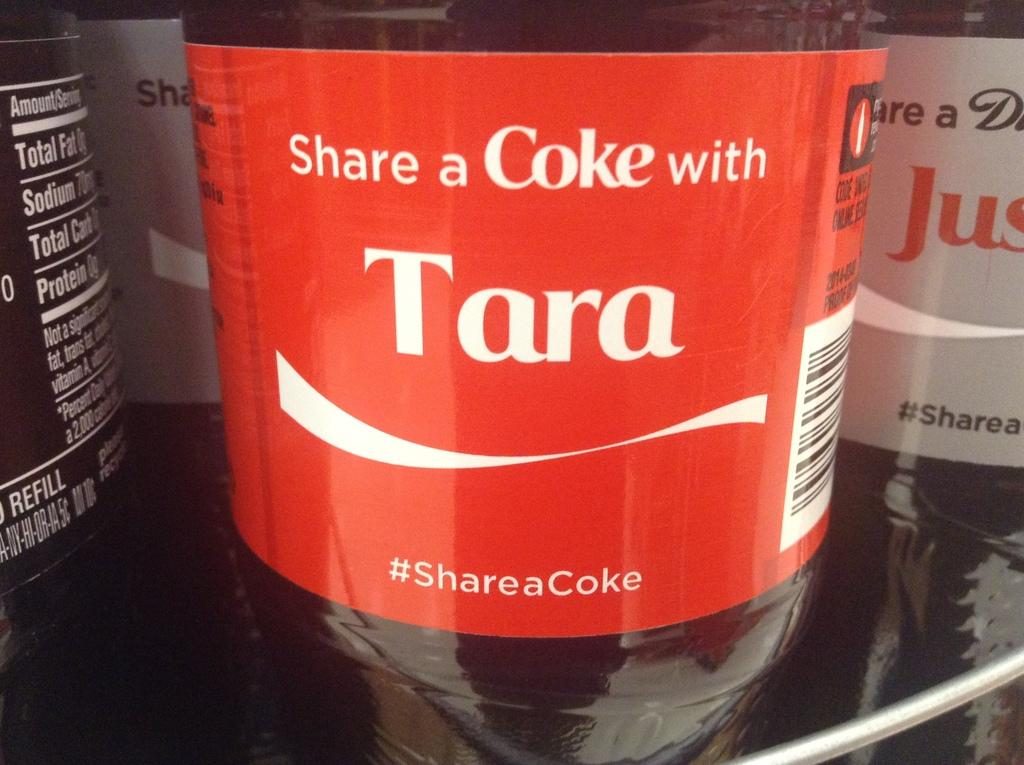<image>
Write a terse but informative summary of the picture. Coca Cola Drink that says Share a Coke with Tara. 